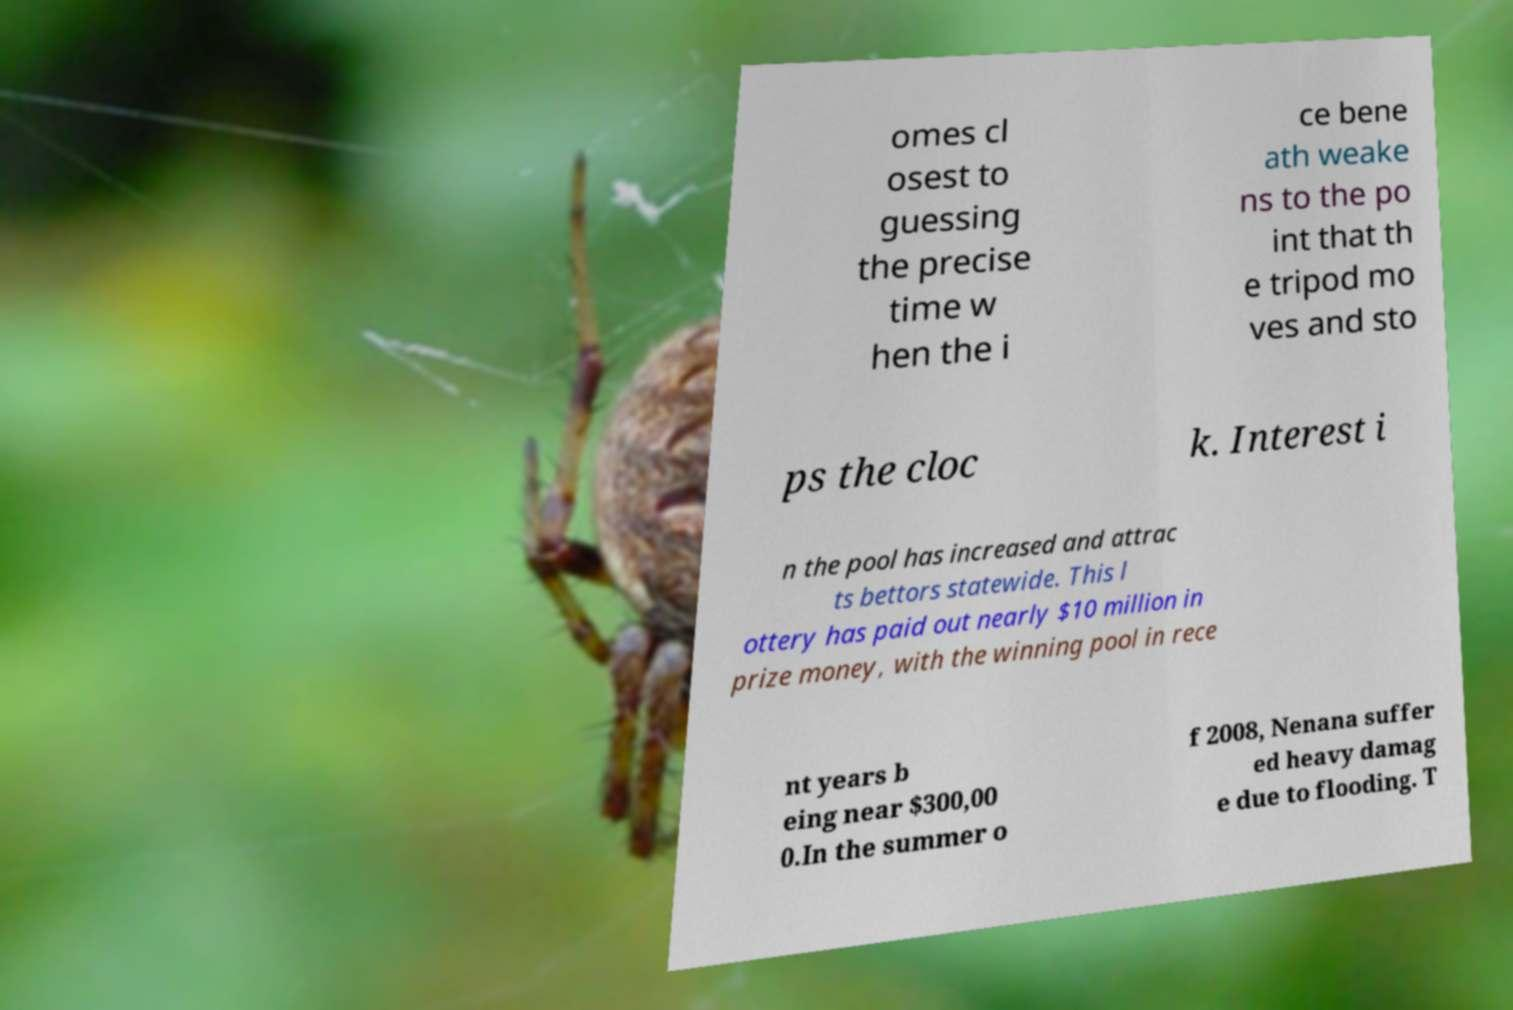Could you extract and type out the text from this image? omes cl osest to guessing the precise time w hen the i ce bene ath weake ns to the po int that th e tripod mo ves and sto ps the cloc k. Interest i n the pool has increased and attrac ts bettors statewide. This l ottery has paid out nearly $10 million in prize money, with the winning pool in rece nt years b eing near $300,00 0.In the summer o f 2008, Nenana suffer ed heavy damag e due to flooding. T 